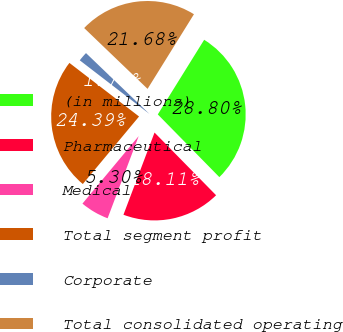<chart> <loc_0><loc_0><loc_500><loc_500><pie_chart><fcel>(in millions)<fcel>Pharmaceutical<fcel>Medical<fcel>Total segment profit<fcel>Corporate<fcel>Total consolidated operating<nl><fcel>28.8%<fcel>18.11%<fcel>5.3%<fcel>24.39%<fcel>1.73%<fcel>21.68%<nl></chart> 